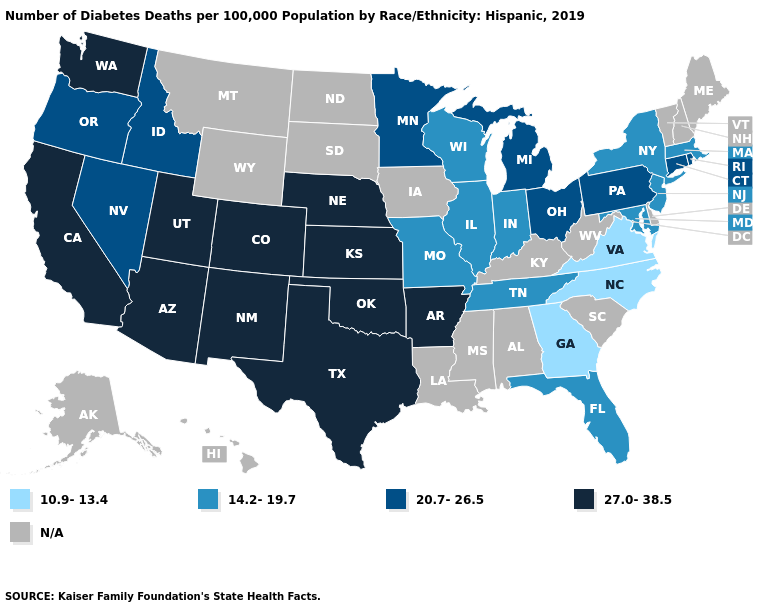How many symbols are there in the legend?
Give a very brief answer. 5. Name the states that have a value in the range 27.0-38.5?
Answer briefly. Arizona, Arkansas, California, Colorado, Kansas, Nebraska, New Mexico, Oklahoma, Texas, Utah, Washington. Does the map have missing data?
Keep it brief. Yes. Name the states that have a value in the range N/A?
Keep it brief. Alabama, Alaska, Delaware, Hawaii, Iowa, Kentucky, Louisiana, Maine, Mississippi, Montana, New Hampshire, North Dakota, South Carolina, South Dakota, Vermont, West Virginia, Wyoming. Which states have the highest value in the USA?
Answer briefly. Arizona, Arkansas, California, Colorado, Kansas, Nebraska, New Mexico, Oklahoma, Texas, Utah, Washington. Name the states that have a value in the range 10.9-13.4?
Concise answer only. Georgia, North Carolina, Virginia. Among the states that border New Hampshire , which have the highest value?
Give a very brief answer. Massachusetts. Which states have the highest value in the USA?
Write a very short answer. Arizona, Arkansas, California, Colorado, Kansas, Nebraska, New Mexico, Oklahoma, Texas, Utah, Washington. What is the value of Iowa?
Be succinct. N/A. Does the first symbol in the legend represent the smallest category?
Short answer required. Yes. Among the states that border Pennsylvania , which have the highest value?
Write a very short answer. Ohio. How many symbols are there in the legend?
Quick response, please. 5. What is the highest value in the USA?
Be succinct. 27.0-38.5. What is the value of Connecticut?
Short answer required. 20.7-26.5. 